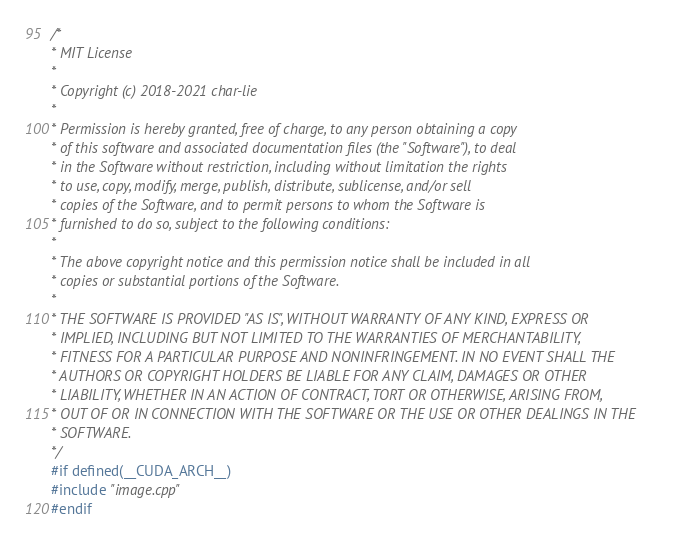Convert code to text. <code><loc_0><loc_0><loc_500><loc_500><_Cuda_>/*
* MIT License
*
* Copyright (c) 2018-2021 char-lie
*
* Permission is hereby granted, free of charge, to any person obtaining a copy
* of this software and associated documentation files (the "Software"), to deal
* in the Software without restriction, including without limitation the rights
* to use, copy, modify, merge, publish, distribute, sublicense, and/or sell
* copies of the Software, and to permit persons to whom the Software is
* furnished to do so, subject to the following conditions:
*
* The above copyright notice and this permission notice shall be included in all
* copies or substantial portions of the Software.
*
* THE SOFTWARE IS PROVIDED "AS IS", WITHOUT WARRANTY OF ANY KIND, EXPRESS OR
* IMPLIED, INCLUDING BUT NOT LIMITED TO THE WARRANTIES OF MERCHANTABILITY,
* FITNESS FOR A PARTICULAR PURPOSE AND NONINFRINGEMENT. IN NO EVENT SHALL THE
* AUTHORS OR COPYRIGHT HOLDERS BE LIABLE FOR ANY CLAIM, DAMAGES OR OTHER
* LIABILITY, WHETHER IN AN ACTION OF CONTRACT, TORT OR OTHERWISE, ARISING FROM,
* OUT OF OR IN CONNECTION WITH THE SOFTWARE OR THE USE OR OTHER DEALINGS IN THE
* SOFTWARE.
*/
#if defined(__CUDA_ARCH__)
#include "image.cpp"
#endif
</code> 